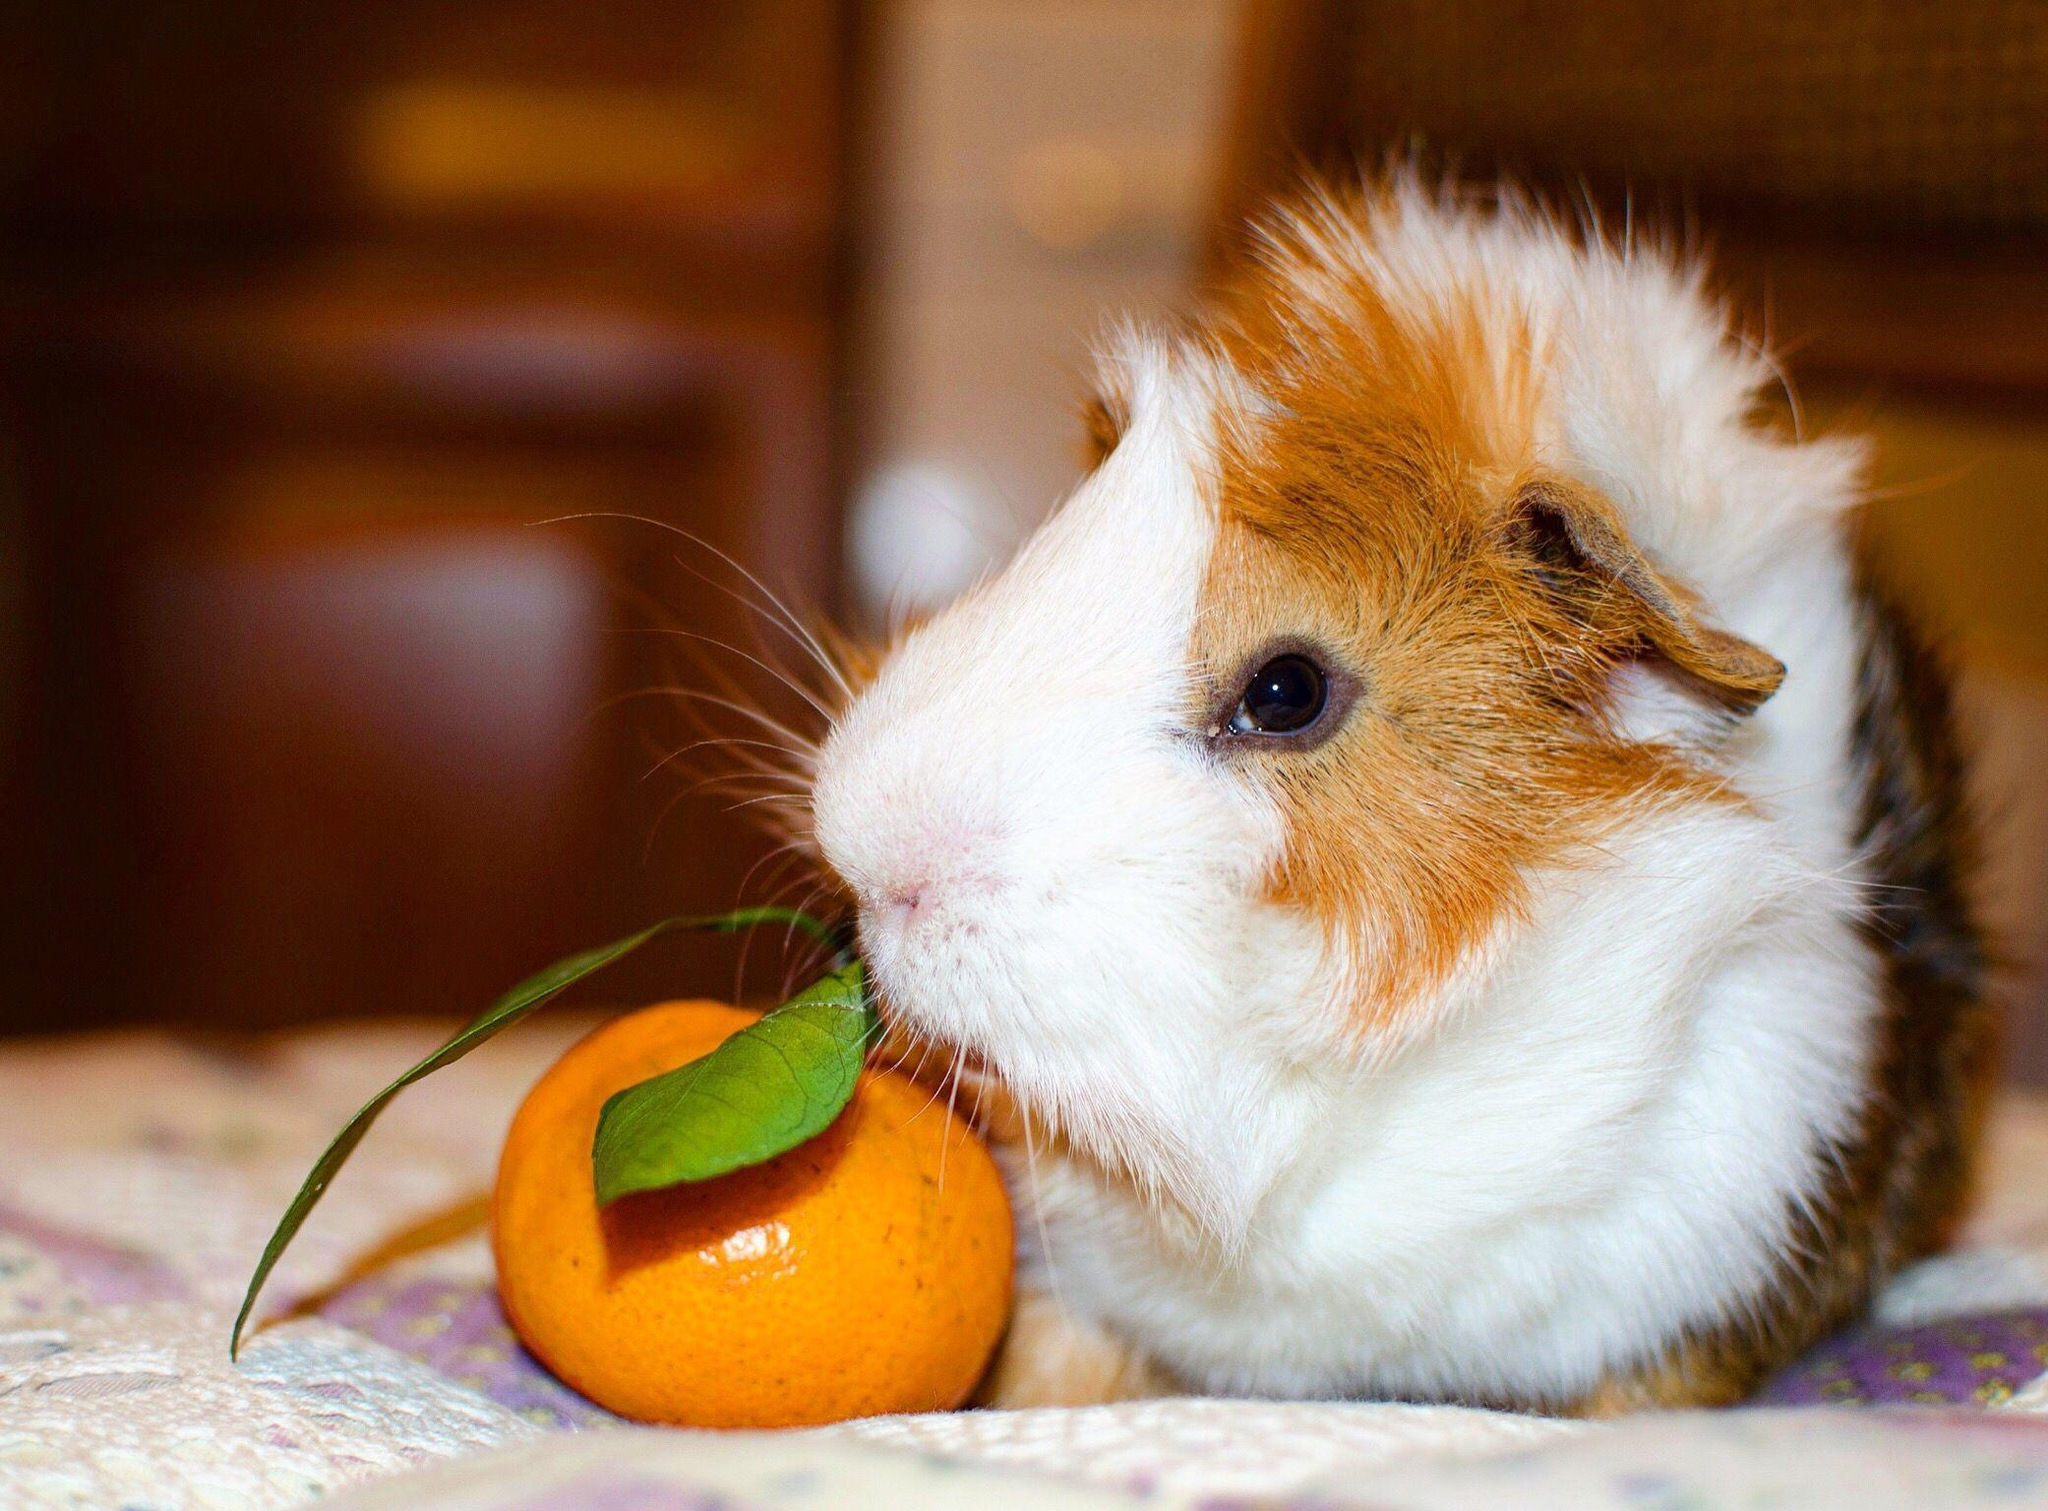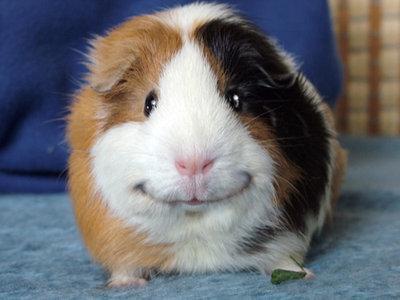The first image is the image on the left, the second image is the image on the right. Considering the images on both sides, is "At least one of the animals is sitting on a soft cushioned material." valid? Answer yes or no. Yes. 